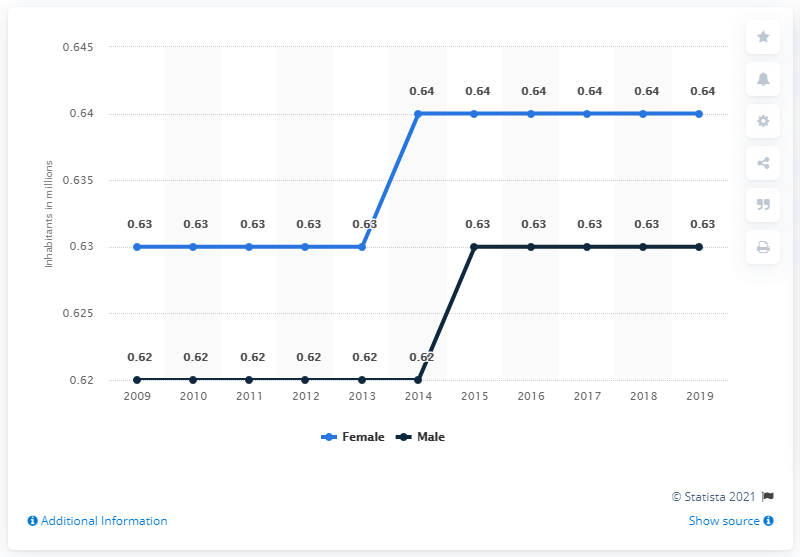Indicate a few pertinent items in this graphic. In 2019, the male population of Mauritius was approximately 0.63 million. The female population of Mauritius in 2019 was 0.64. 